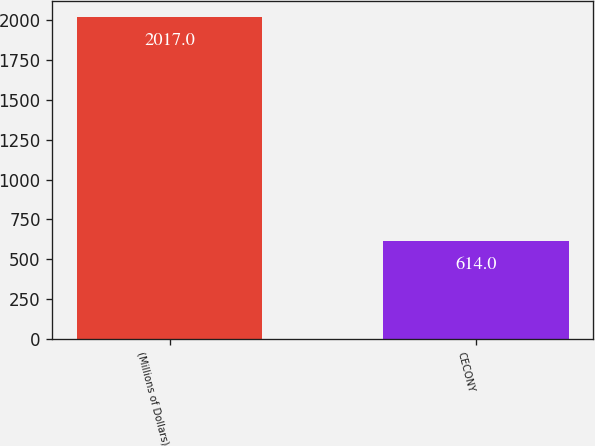Convert chart. <chart><loc_0><loc_0><loc_500><loc_500><bar_chart><fcel>(Millions of Dollars)<fcel>CECONY<nl><fcel>2017<fcel>614<nl></chart> 